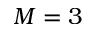<formula> <loc_0><loc_0><loc_500><loc_500>M = 3</formula> 